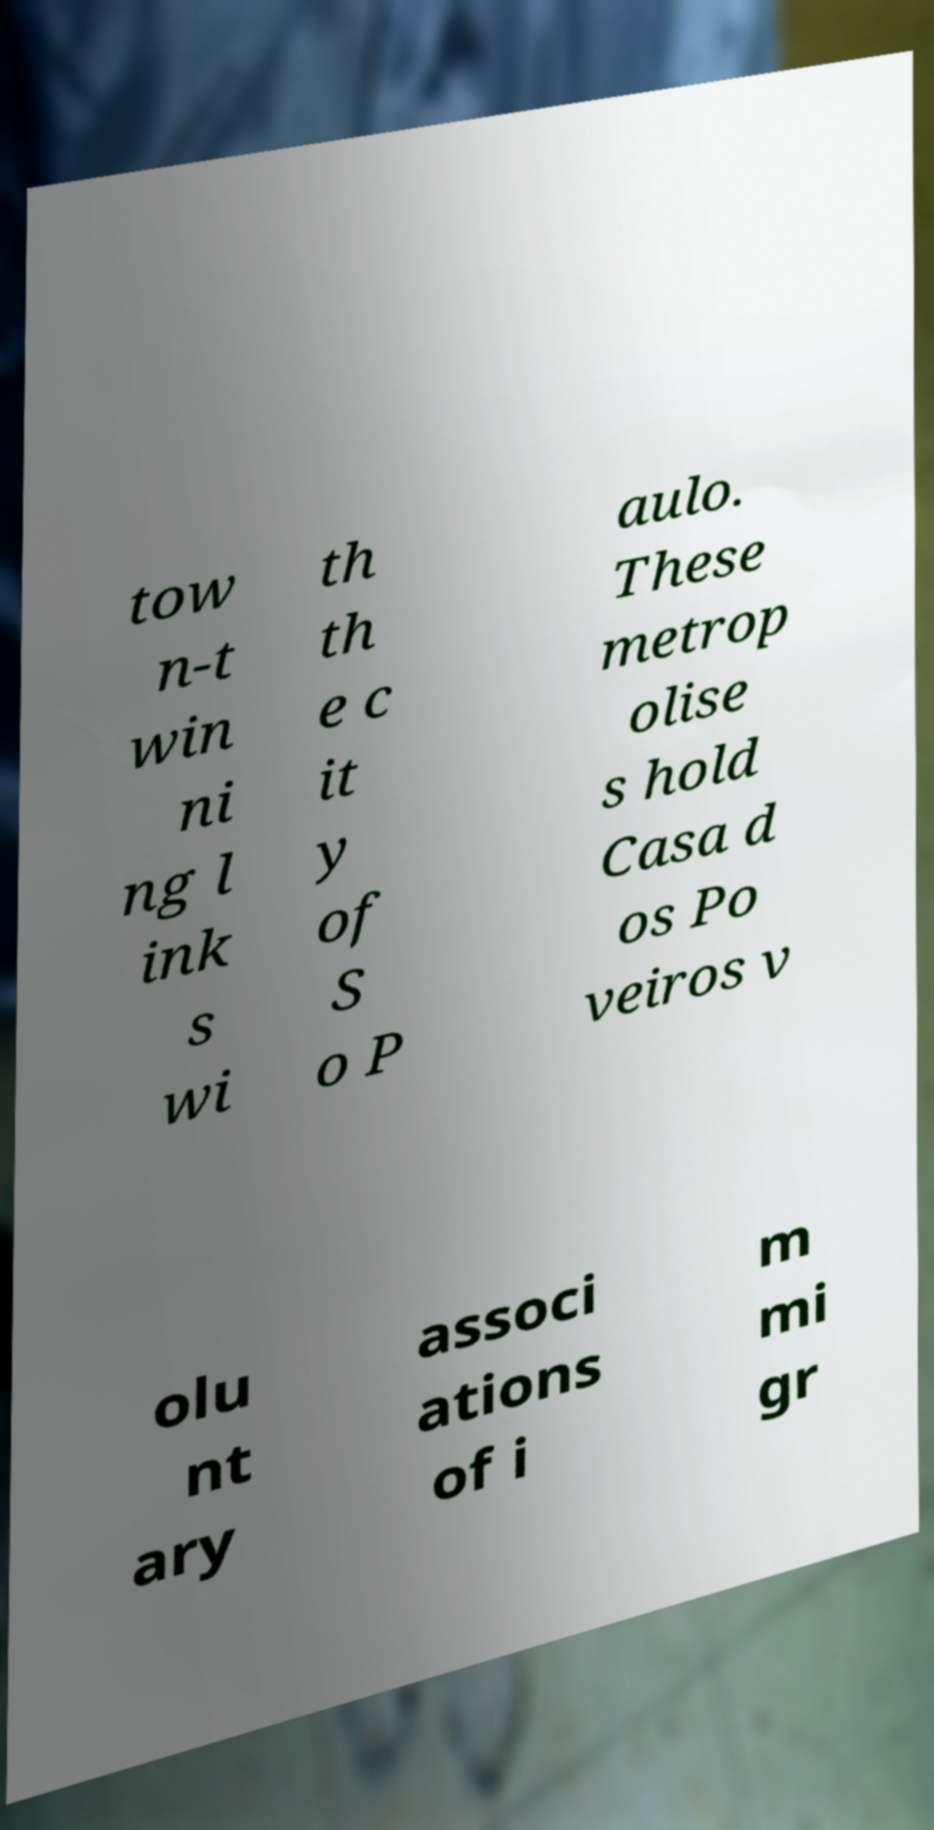For documentation purposes, I need the text within this image transcribed. Could you provide that? tow n-t win ni ng l ink s wi th th e c it y of S o P aulo. These metrop olise s hold Casa d os Po veiros v olu nt ary associ ations of i m mi gr 